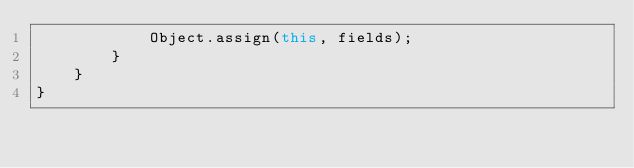<code> <loc_0><loc_0><loc_500><loc_500><_TypeScript_>			Object.assign(this, fields);
		}
	}
}
</code> 